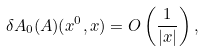Convert formula to latex. <formula><loc_0><loc_0><loc_500><loc_500>\delta A _ { 0 } ( { A } ) ( x ^ { 0 } , { x } ) = O \left ( \frac { 1 } { | { x } | } \right ) ,</formula> 